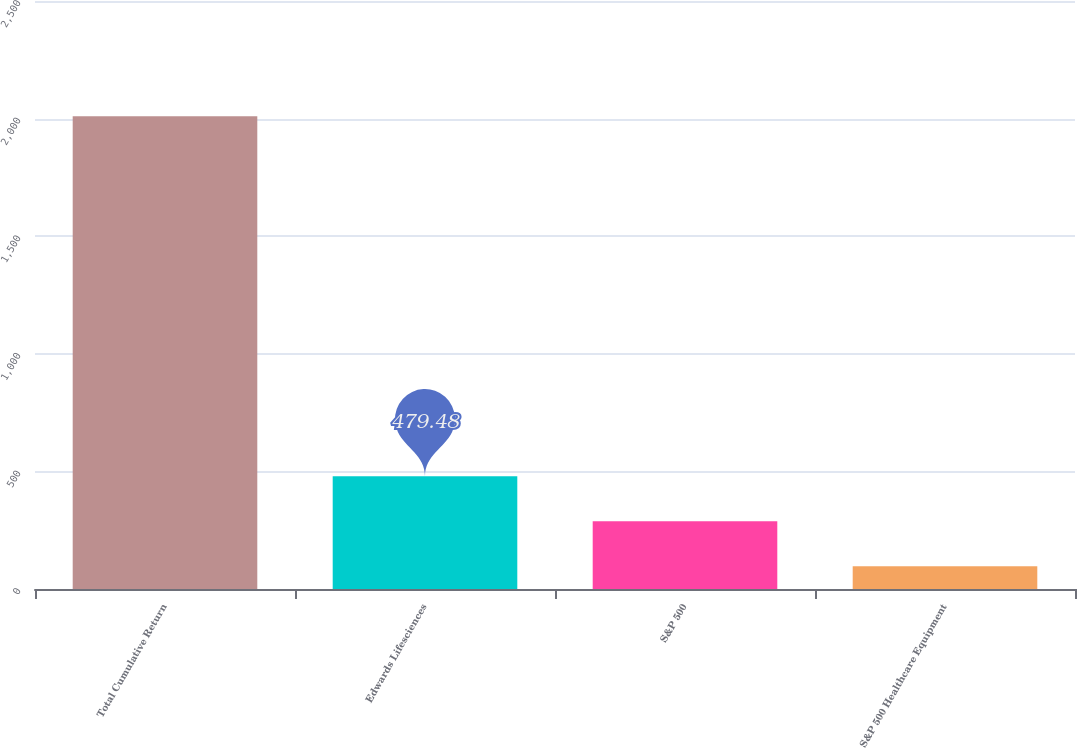Convert chart. <chart><loc_0><loc_0><loc_500><loc_500><bar_chart><fcel>Total Cumulative Return<fcel>Edwards Lifesciences<fcel>S&P 500<fcel>S&P 500 Healthcare Equipment<nl><fcel>2010<fcel>479.48<fcel>288.16<fcel>96.84<nl></chart> 